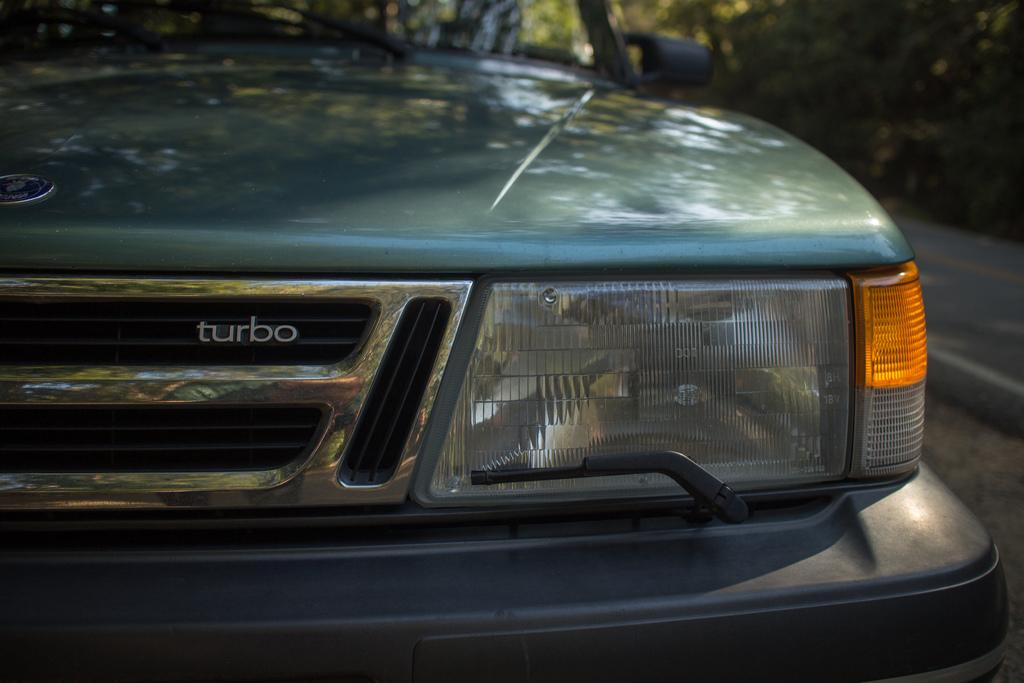What is the main subject of the image? The main subject of the image is a car. Where is the car located in the image? The car is standing on the road in the image. What additional detail can be seen on the car? The car has "Turbo" written on it. What type of fan is visible in the image? There is no fan present in the image; it features a car standing on the road with "Turbo" written on it. 